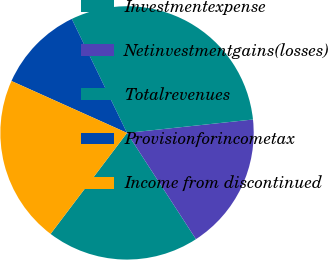<chart> <loc_0><loc_0><loc_500><loc_500><pie_chart><fcel>Investmentexpense<fcel>Netinvestmentgains(losses)<fcel>Totalrevenues<fcel>Provisionforincometax<fcel>Income from discontinued<nl><fcel>19.47%<fcel>17.53%<fcel>30.5%<fcel>11.1%<fcel>21.41%<nl></chart> 